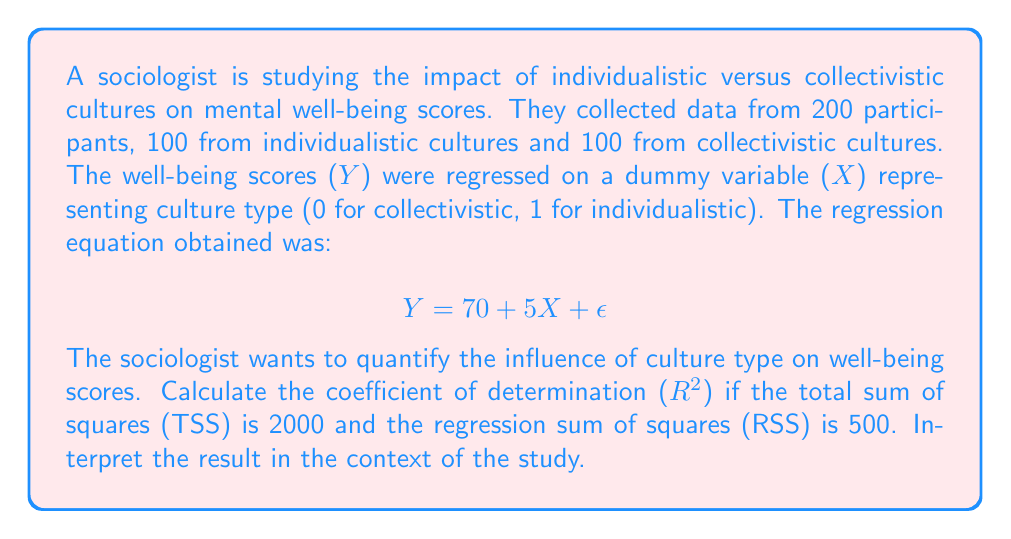Can you answer this question? To solve this problem, we need to follow these steps:

1) Recall that the coefficient of determination ($R^2$) is calculated as:

   $$ R^2 = \frac{RSS}{TSS} $$

   where RSS is the regression sum of squares and TSS is the total sum of squares.

2) We are given:
   TSS = 2000
   RSS = 500

3) Substituting these values into the formula:

   $$ R^2 = \frac{500}{2000} = 0.25 $$

4) To interpret this result:
   - $R^2$ represents the proportion of variance in the dependent variable (well-being scores) that is predictable from the independent variable (culture type).
   - In this case, 25% of the variability in well-being scores can be explained by the culture type (individualistic vs. collectivistic).
   - This suggests a moderate influence of culture type on well-being scores, but also indicates that 75% of the variability is due to other factors not accounted for in this simple regression model.

5) In the context of the study:
   - The regression equation $Y = 70 + 5X + \epsilon$ indicates that, on average, individuals from individualistic cultures score 5 points higher on the well-being scale than those from collectivistic cultures.
   - However, the $R^2$ value suggests that while culture type does have an influence, it's not the sole or even the primary determinant of well-being scores.
   - This aligns with the sociologist's argument that mental well-being is an individualistic construct influenced by societal norms, as it shows both individual variation and cultural influence.
Answer: The coefficient of determination ($R^2$) is 0.25, indicating that 25% of the variability in well-being scores can be explained by the culture type (individualistic vs. collectivistic). 